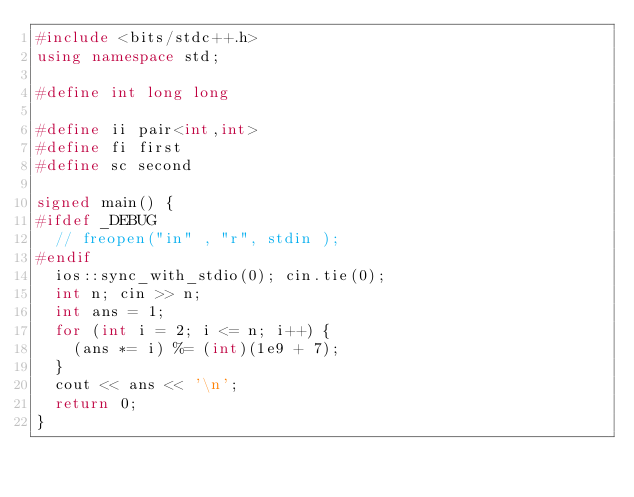<code> <loc_0><loc_0><loc_500><loc_500><_C++_>#include <bits/stdc++.h>
using namespace std;

#define int long long

#define ii pair<int,int>
#define fi first
#define sc second

signed main() {
#ifdef _DEBUG
  // freopen("in" , "r", stdin );
#endif
  ios::sync_with_stdio(0); cin.tie(0);
  int n; cin >> n;
  int ans = 1;
  for (int i = 2; i <= n; i++) {
    (ans *= i) %= (int)(1e9 + 7);
  }
  cout << ans << '\n';
  return 0;
}
</code> 